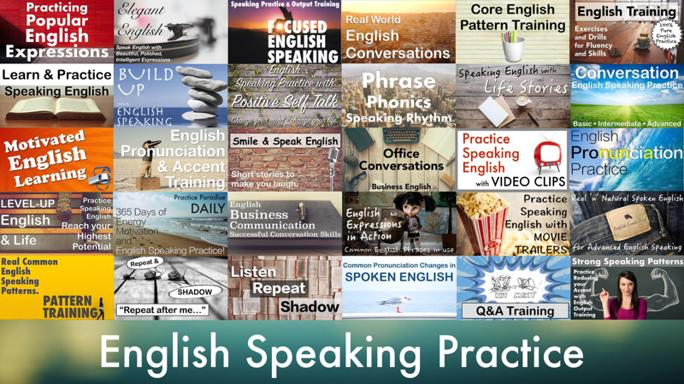What is common among the phrases in the image?
 The common theme among the phrases in the image is practicing and improving English speaking. What are some of the methods mentioned in the image for improving English speaking? The image mentions popular English expressions, focused pattern training, real-world English, learning English phrases, building speaking practice, positive self-talk, phonics, rhythm, practicing pronunciation, improving accent, listening, shadow pattern training, and practicing through video clips and daily business English. 